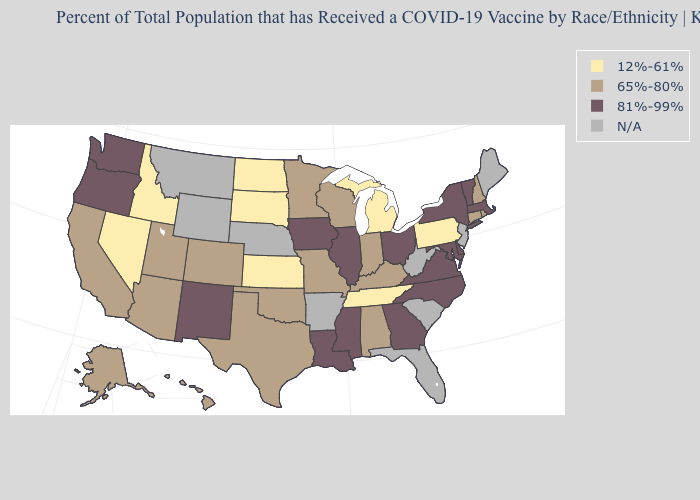What is the highest value in states that border Maryland?
Write a very short answer. 81%-99%. Name the states that have a value in the range N/A?
Write a very short answer. Arkansas, Florida, Maine, Montana, Nebraska, New Jersey, South Carolina, West Virginia, Wyoming. What is the value of Illinois?
Keep it brief. 81%-99%. What is the value of Louisiana?
Write a very short answer. 81%-99%. Does Wisconsin have the lowest value in the MidWest?
Quick response, please. No. Does New York have the lowest value in the Northeast?
Be succinct. No. Among the states that border Colorado , does New Mexico have the highest value?
Keep it brief. Yes. Name the states that have a value in the range N/A?
Give a very brief answer. Arkansas, Florida, Maine, Montana, Nebraska, New Jersey, South Carolina, West Virginia, Wyoming. Name the states that have a value in the range 65%-80%?
Short answer required. Alabama, Alaska, Arizona, California, Colorado, Connecticut, Hawaii, Indiana, Kentucky, Minnesota, Missouri, New Hampshire, Oklahoma, Rhode Island, Texas, Utah, Wisconsin. Which states have the lowest value in the Northeast?
Keep it brief. Pennsylvania. Does Tennessee have the lowest value in the USA?
Answer briefly. Yes. Name the states that have a value in the range 65%-80%?
Quick response, please. Alabama, Alaska, Arizona, California, Colorado, Connecticut, Hawaii, Indiana, Kentucky, Minnesota, Missouri, New Hampshire, Oklahoma, Rhode Island, Texas, Utah, Wisconsin. What is the value of Maryland?
Write a very short answer. 81%-99%. 